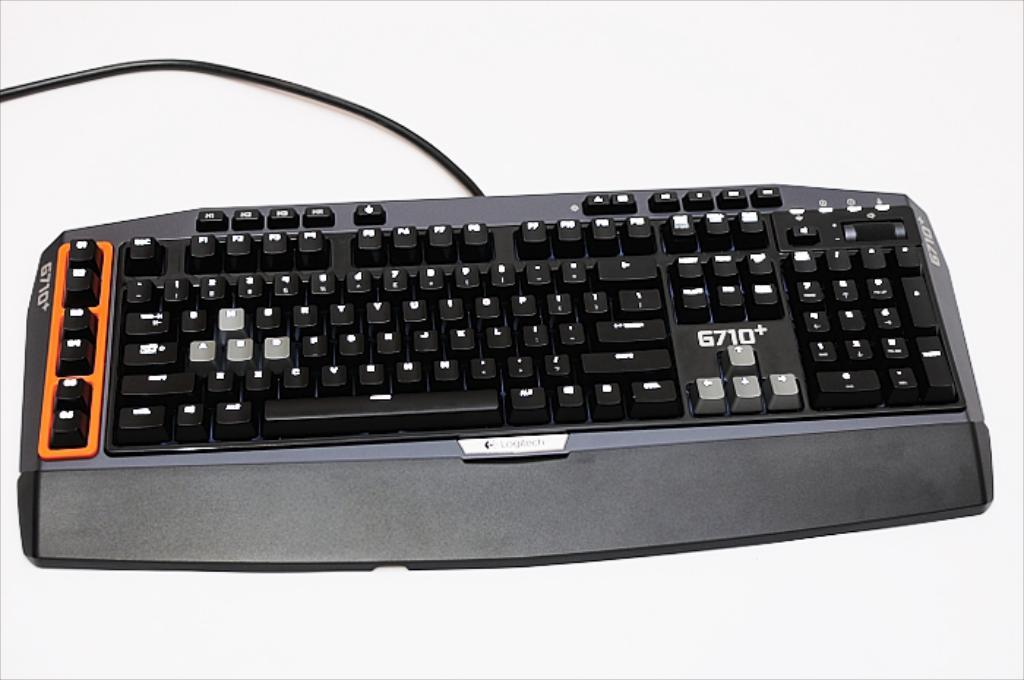What is the main object in the image? There is a keyboard in the image. What else can be seen in the image besides the keyboard? There is a wire visible in the image. What is the color of the surface on which the keyboard and wire are placed? Both the keyboard and wire are on a white surface. What color is present in the image besides white? There is an orange color visible in the image. What type of brass instrument is being played in the image? There is no brass instrument present in the image; it features a keyboard and a wire on a white surface. 